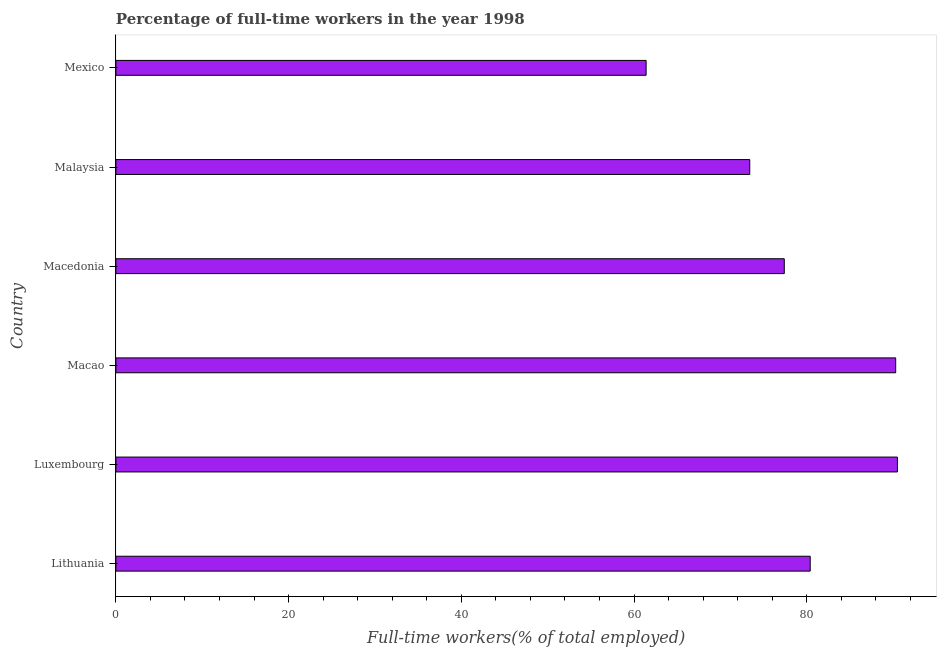Does the graph contain grids?
Your response must be concise. No. What is the title of the graph?
Provide a succinct answer. Percentage of full-time workers in the year 1998. What is the label or title of the X-axis?
Your answer should be very brief. Full-time workers(% of total employed). What is the label or title of the Y-axis?
Ensure brevity in your answer.  Country. What is the percentage of full-time workers in Macao?
Your answer should be very brief. 90.3. Across all countries, what is the maximum percentage of full-time workers?
Ensure brevity in your answer.  90.5. Across all countries, what is the minimum percentage of full-time workers?
Make the answer very short. 61.4. In which country was the percentage of full-time workers maximum?
Keep it short and to the point. Luxembourg. In which country was the percentage of full-time workers minimum?
Make the answer very short. Mexico. What is the sum of the percentage of full-time workers?
Offer a very short reply. 473.4. What is the average percentage of full-time workers per country?
Keep it short and to the point. 78.9. What is the median percentage of full-time workers?
Provide a succinct answer. 78.9. What is the ratio of the percentage of full-time workers in Lithuania to that in Mexico?
Ensure brevity in your answer.  1.31. Is the percentage of full-time workers in Macao less than that in Macedonia?
Your response must be concise. No. What is the difference between the highest and the second highest percentage of full-time workers?
Offer a very short reply. 0.2. Is the sum of the percentage of full-time workers in Luxembourg and Macedonia greater than the maximum percentage of full-time workers across all countries?
Make the answer very short. Yes. What is the difference between the highest and the lowest percentage of full-time workers?
Offer a very short reply. 29.1. In how many countries, is the percentage of full-time workers greater than the average percentage of full-time workers taken over all countries?
Offer a very short reply. 3. How many bars are there?
Give a very brief answer. 6. Are all the bars in the graph horizontal?
Keep it short and to the point. Yes. How many countries are there in the graph?
Your response must be concise. 6. What is the difference between two consecutive major ticks on the X-axis?
Your answer should be compact. 20. What is the Full-time workers(% of total employed) in Lithuania?
Provide a succinct answer. 80.4. What is the Full-time workers(% of total employed) in Luxembourg?
Your response must be concise. 90.5. What is the Full-time workers(% of total employed) in Macao?
Give a very brief answer. 90.3. What is the Full-time workers(% of total employed) in Macedonia?
Ensure brevity in your answer.  77.4. What is the Full-time workers(% of total employed) of Malaysia?
Give a very brief answer. 73.4. What is the Full-time workers(% of total employed) in Mexico?
Your answer should be compact. 61.4. What is the difference between the Full-time workers(% of total employed) in Lithuania and Luxembourg?
Your answer should be very brief. -10.1. What is the difference between the Full-time workers(% of total employed) in Lithuania and Malaysia?
Your answer should be very brief. 7. What is the difference between the Full-time workers(% of total employed) in Luxembourg and Macao?
Provide a succinct answer. 0.2. What is the difference between the Full-time workers(% of total employed) in Luxembourg and Macedonia?
Make the answer very short. 13.1. What is the difference between the Full-time workers(% of total employed) in Luxembourg and Mexico?
Make the answer very short. 29.1. What is the difference between the Full-time workers(% of total employed) in Macao and Mexico?
Your answer should be compact. 28.9. What is the difference between the Full-time workers(% of total employed) in Macedonia and Mexico?
Your answer should be very brief. 16. What is the difference between the Full-time workers(% of total employed) in Malaysia and Mexico?
Your answer should be very brief. 12. What is the ratio of the Full-time workers(% of total employed) in Lithuania to that in Luxembourg?
Make the answer very short. 0.89. What is the ratio of the Full-time workers(% of total employed) in Lithuania to that in Macao?
Make the answer very short. 0.89. What is the ratio of the Full-time workers(% of total employed) in Lithuania to that in Macedonia?
Keep it short and to the point. 1.04. What is the ratio of the Full-time workers(% of total employed) in Lithuania to that in Malaysia?
Offer a very short reply. 1.09. What is the ratio of the Full-time workers(% of total employed) in Lithuania to that in Mexico?
Keep it short and to the point. 1.31. What is the ratio of the Full-time workers(% of total employed) in Luxembourg to that in Macao?
Offer a terse response. 1. What is the ratio of the Full-time workers(% of total employed) in Luxembourg to that in Macedonia?
Offer a very short reply. 1.17. What is the ratio of the Full-time workers(% of total employed) in Luxembourg to that in Malaysia?
Provide a succinct answer. 1.23. What is the ratio of the Full-time workers(% of total employed) in Luxembourg to that in Mexico?
Provide a succinct answer. 1.47. What is the ratio of the Full-time workers(% of total employed) in Macao to that in Macedonia?
Ensure brevity in your answer.  1.17. What is the ratio of the Full-time workers(% of total employed) in Macao to that in Malaysia?
Your answer should be very brief. 1.23. What is the ratio of the Full-time workers(% of total employed) in Macao to that in Mexico?
Give a very brief answer. 1.47. What is the ratio of the Full-time workers(% of total employed) in Macedonia to that in Malaysia?
Your answer should be compact. 1.05. What is the ratio of the Full-time workers(% of total employed) in Macedonia to that in Mexico?
Provide a succinct answer. 1.26. What is the ratio of the Full-time workers(% of total employed) in Malaysia to that in Mexico?
Your response must be concise. 1.2. 